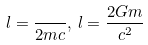Convert formula to latex. <formula><loc_0><loc_0><loc_500><loc_500>l = \frac { } { 2 m c } , \, l = \frac { 2 G m } { c ^ { 2 } }</formula> 